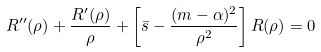<formula> <loc_0><loc_0><loc_500><loc_500>R ^ { \prime \prime } ( \rho ) + \frac { R ^ { \prime } ( \rho ) } { \rho } + \left [ \bar { s } - \frac { ( m - \alpha ) ^ { 2 } } { \rho ^ { 2 } } \right ] R ( \rho ) = 0</formula> 